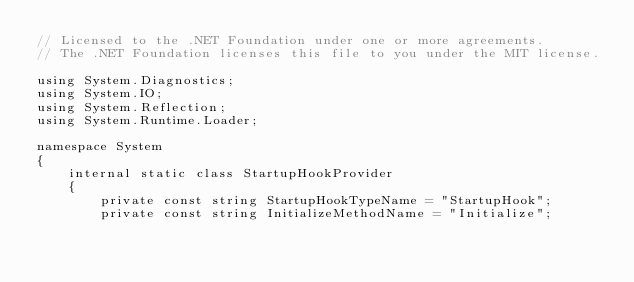Convert code to text. <code><loc_0><loc_0><loc_500><loc_500><_C#_>// Licensed to the .NET Foundation under one or more agreements.
// The .NET Foundation licenses this file to you under the MIT license.

using System.Diagnostics;
using System.IO;
using System.Reflection;
using System.Runtime.Loader;

namespace System
{
    internal static class StartupHookProvider
    {
        private const string StartupHookTypeName = "StartupHook";
        private const string InitializeMethodName = "Initialize";</code> 